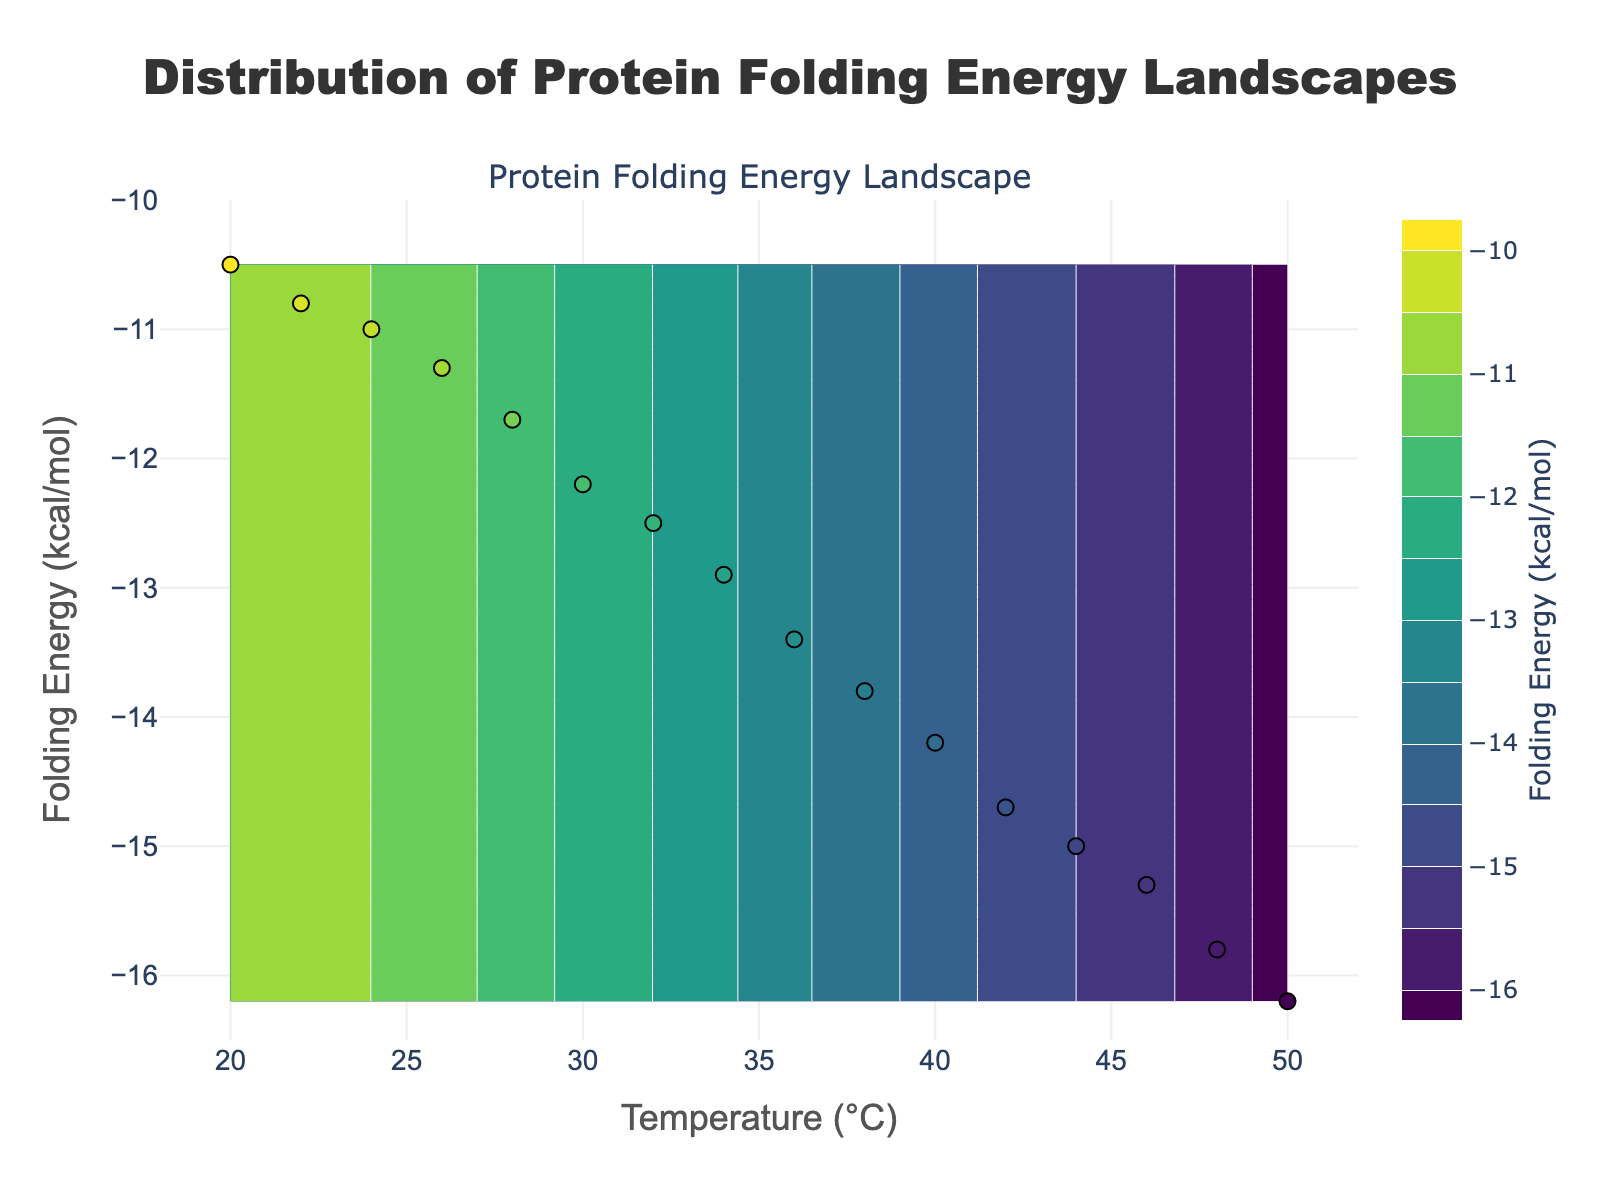What is the temperature range shown in the plot? The temperature axis (x-axis) ranges from 18°C to 52°C as indicated by the axis limits and labels.
Answer: 18°C to 52°C What is the axis title for the y-axis? The axis title for the y-axis is "Folding Energy (kcal/mol)" as indicated in the plot.
Answer: Folding Energy (kcal/mol) How does the folding energy change with increasing temperature? As temperature increases from 20°C to 50°C, the folding energy becomes more negative, indicating a decrease in folding energy with increasing temperature.
Answer: Decreases What is the minimum folding energy observed in the plot? The minimum folding energy in the plot is -16.2 kcal/mol, as seen at the highest temperature point (50°C).
Answer: -16.2 kcal/mol Which temperature corresponds to a folding energy of -14.2 kcal/mol? According to the scatter points on the plot, a temperature of 40°C corresponds to a folding energy of -14.2 kcal/mol.
Answer: 40°C What is the color scheme used for the contour plot? The color scheme used for the contour plot is "Viridis," which ranges from dark purple to yellow-green.
Answer: Viridis How many temperature and folding energy pairs are represented in the scatter plot? There are 16 pairs of temperature and folding energy values as represented by the scatter plot markers.
Answer: 16 What can you infer about the relationship between temperature and folding energy from the contour plot? The contour plot shows that a higher temperature generally corresponds to a more negative folding energy, indicating a consistent decrease in folding energy with an increase in temperature. The contour lines run approximately parallel to the temperature axis, indicating a smooth and continuous relationship.
Answer: More negative folding energy at higher temperatures 